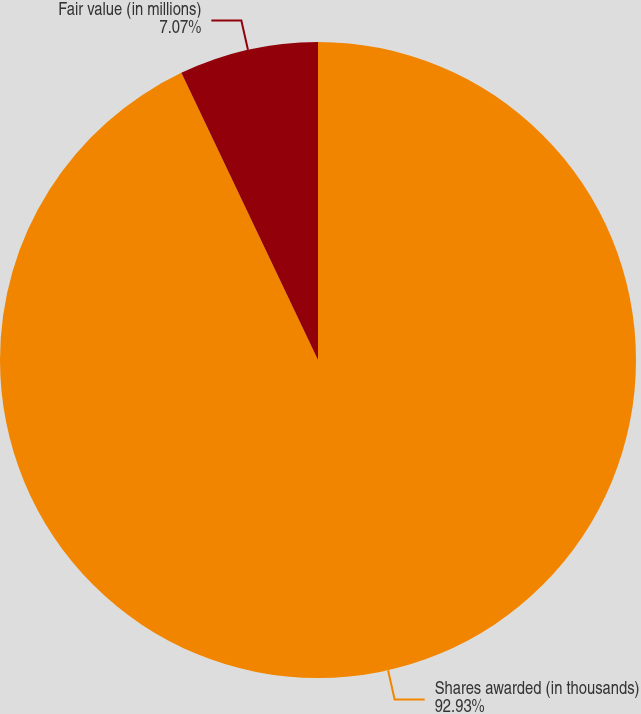<chart> <loc_0><loc_0><loc_500><loc_500><pie_chart><fcel>Shares awarded (in thousands)<fcel>Fair value (in millions)<nl><fcel>92.93%<fcel>7.07%<nl></chart> 